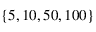Convert formula to latex. <formula><loc_0><loc_0><loc_500><loc_500>\{ 5 , 1 0 , 5 0 , 1 0 0 \}</formula> 